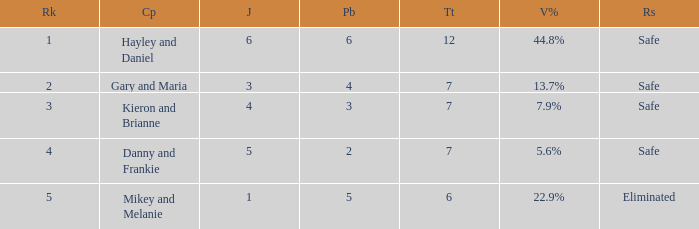What was the maximum rank for the vote percentage of 5.6% 4.0. 